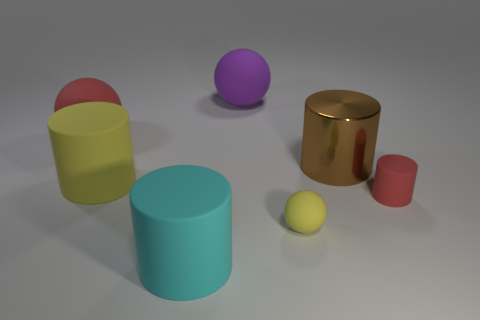How does the lighting affect the appearance of the objects? The lighting in the image appears to be coming from the upper left as evidenced by the shadows falling to the right of the objects. It creates a soft and even illumination, highlighting the colors and textures of the objects without casting harsh shadows or bright highlights.  Is there any object that stands out in the image due to its size or position? The mint green cylinder stands out due to its central placement and its height. It's the tallest object and is positioned in the center, which draws the viewer's eye to it. 